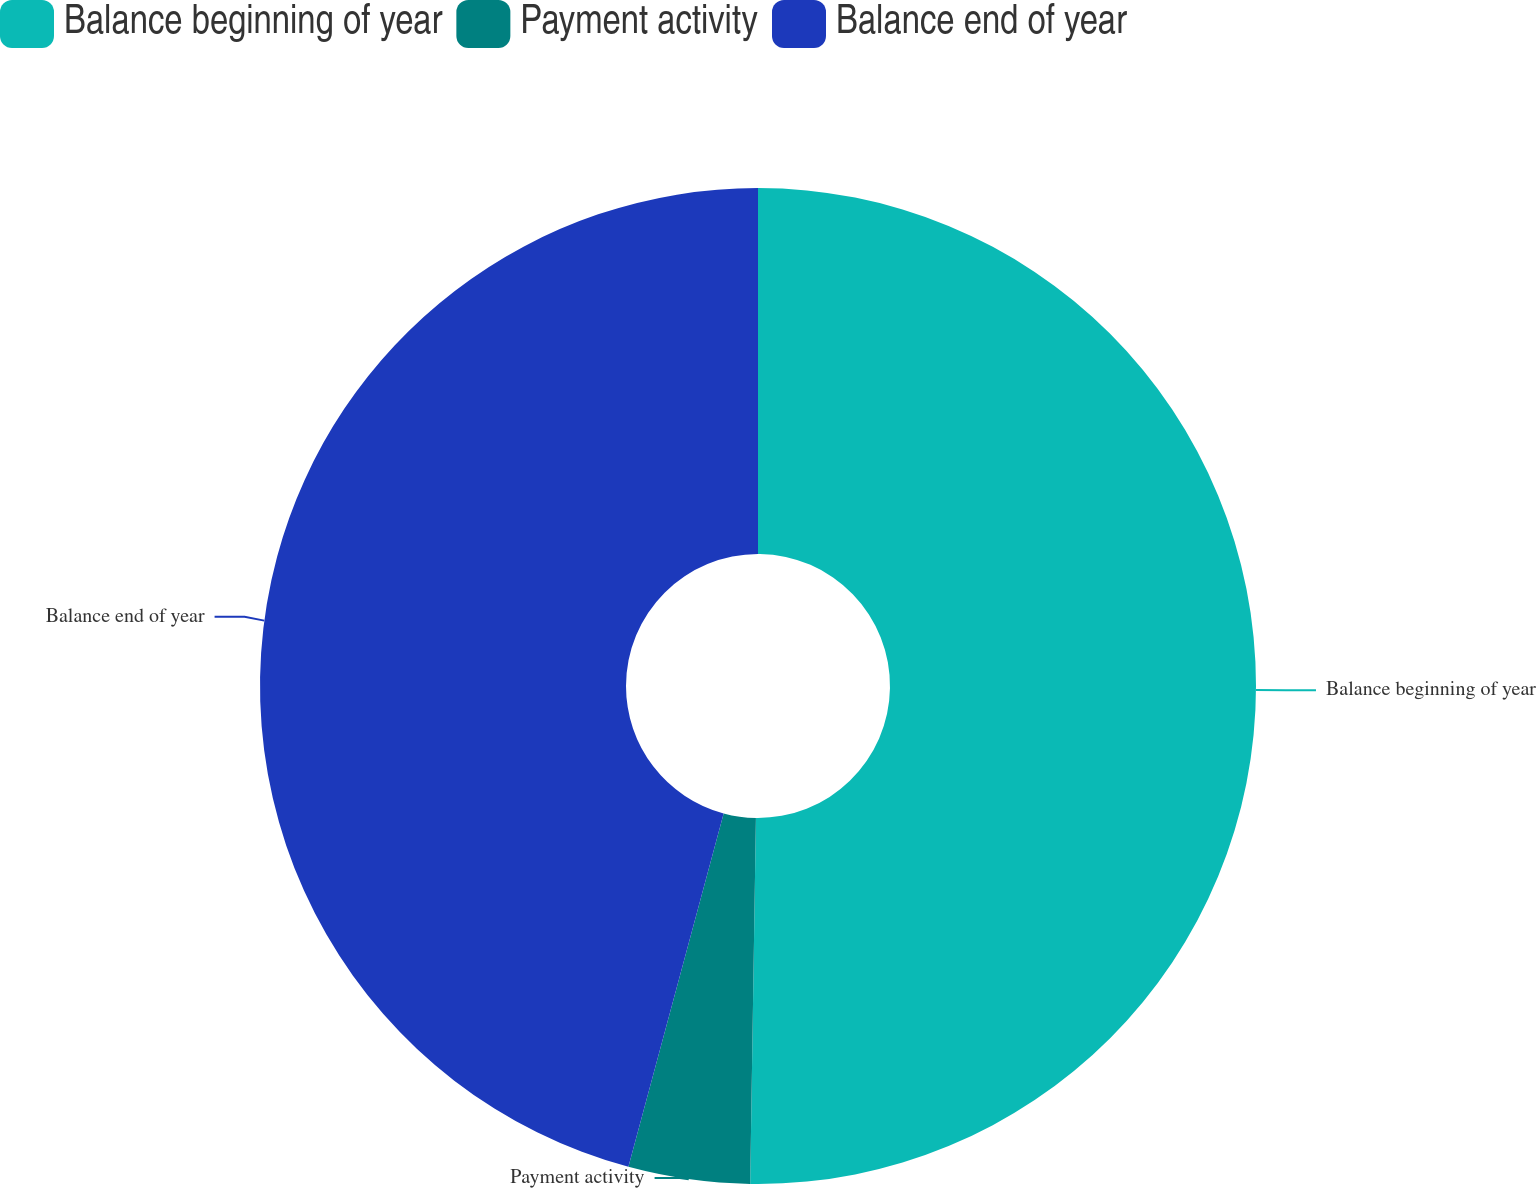Convert chart to OTSL. <chart><loc_0><loc_0><loc_500><loc_500><pie_chart><fcel>Balance beginning of year<fcel>Payment activity<fcel>Balance end of year<nl><fcel>50.25%<fcel>3.94%<fcel>45.81%<nl></chart> 